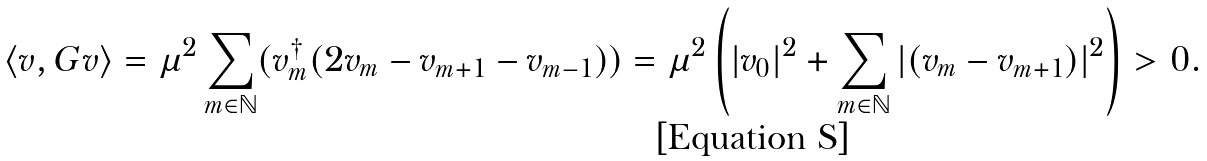<formula> <loc_0><loc_0><loc_500><loc_500>\langle v , G v \rangle = \mu ^ { 2 } \sum _ { m \in \mathbb { N } } ( v _ { m } ^ { \dag } ( 2 v _ { m } - v _ { m + 1 } - v _ { m - 1 } ) ) = \mu ^ { 2 } \left ( | v _ { 0 } | ^ { 2 } + \sum _ { m \in \mathbb { N } } | ( v _ { m } - v _ { m + 1 } ) | ^ { 2 } \right ) > 0 .</formula> 